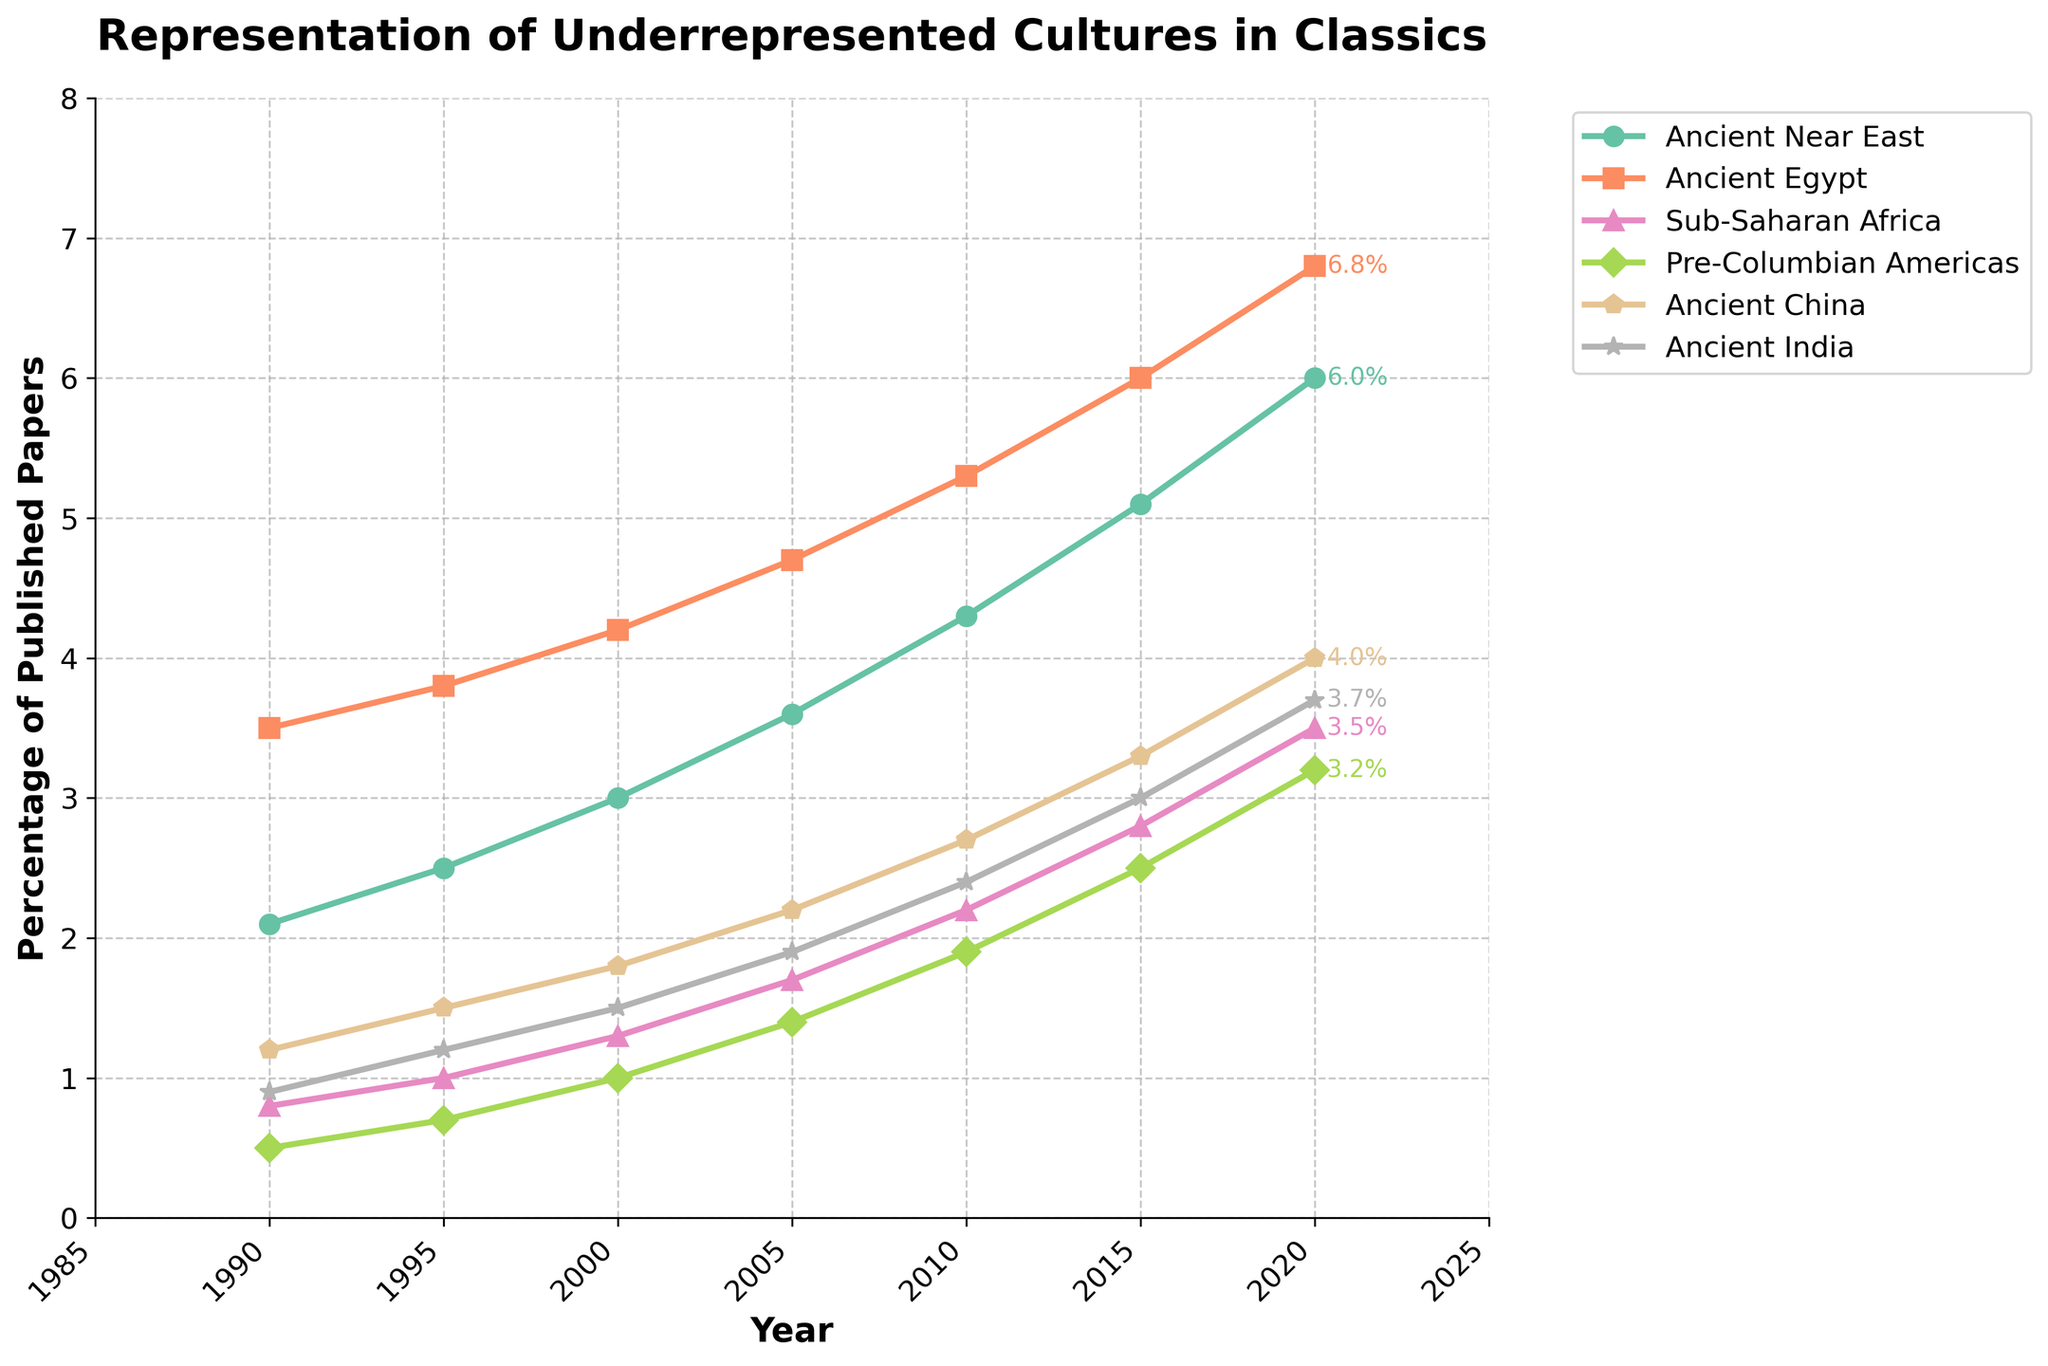What is the general trend for the percentage of papers featuring the Ancient Near East from 1990 to 2020? The line depicting the Ancient Near East shows a consistent upward trend from 1990 to 2020. The percentage starts at 2.1% in 1990 and increases steadily to 6.0% in 2020.
Answer: Upward trend Which underrepresented culture saw the most significant increase in the percentage of published papers from 1990 to 2020? By comparing the starting and ending percentages of all the cultures, Ancient Near East increased from 2.1% to 6.0%, which is a total increase of 3.9%. This is the largest increase among all the cultures depicted.
Answer: Ancient Near East In which year do Ancient Egypt and Sub-Saharan Africa first reach above 5% and 3%, respectively? The line representing Ancient Egypt surpasses 5% in 2010, and the line for Sub-Saharan Africa surpasses 3% in 2020.
Answer: 2010 and 2020 Which culture had the lowest percentage of published papers in 2000, and what was that percentage? In 2000, Pre-Columbian Americas had the lowest percentage at 1.0%.
Answer: Pre-Columbian Americas, 1.0% Compare the percentage increase of Ancient China from 1990 to 2020 with the percentage increase of Sub-Saharan Africa over the same period. For Ancient China, the increase is 4.0% - 1.2% = 2.8%. For Sub-Saharan Africa, the increase is 3.5% - 0.8% = 2.7%. Ancient China had a slightly higher increase.
Answer: Ancient China's increase of 2.8% is slightly higher than Sub-Saharan Africa's increase of 2.7% What is the average percentage of published papers featuring Ancient India from 2000 to 2020? Summing the percentages of Ancient India from 2000 to 2020 gives 1.5+1.9+2.4+3.0+3.7 = 12.5. The time span is 5 data points, so the average is 12.5 / 5 = 2.5%.
Answer: 2.5% Which two underrepresented cultures had their percentage values closest to each other in 2020, and what were those values? In 2020, the two closest values were for Ancient China at 4.0% and Ancient India at 3.7%. The difference between them is 0.3%.
Answer: Ancient China: 4.0%, Ancient India: 3.7% What is the total increase in the percentage of papers featuring underrepresented cultures from 1990 to 2020 for all cultures combined? Summing the increases for each culture from 1990 to 2020 gives (6.0-2.1) + (6.8-3.5) + (3.5-0.8) + (3.2-0.5) + (4.0-1.2) + (3.7-0.9) = 3.9 + 3.3 + 2.7 + 2.7 + 2.8 + 2.8 = 18.2%.
Answer: 18.2% Which culture had the highest percentage of published papers in 2015, and what was that percentage? The highest percentage in 2015 was for Ancient Egypt at 6.0%.
Answer: Ancient Egypt, 6.0% What percentage of published papers featured Pre-Columbian Americas in 2010, and how does this compare to Sub-Saharan Africa in the same year? In 2010, Pre-Columbian Americas had 1.9%, whereas Sub-Saharan Africa had 2.2%. Sub-Saharan Africa's percentage was higher by 0.3%.
Answer: Pre-Columbian Americas: 1.9%, Sub-Saharan Africa: 2.2% 